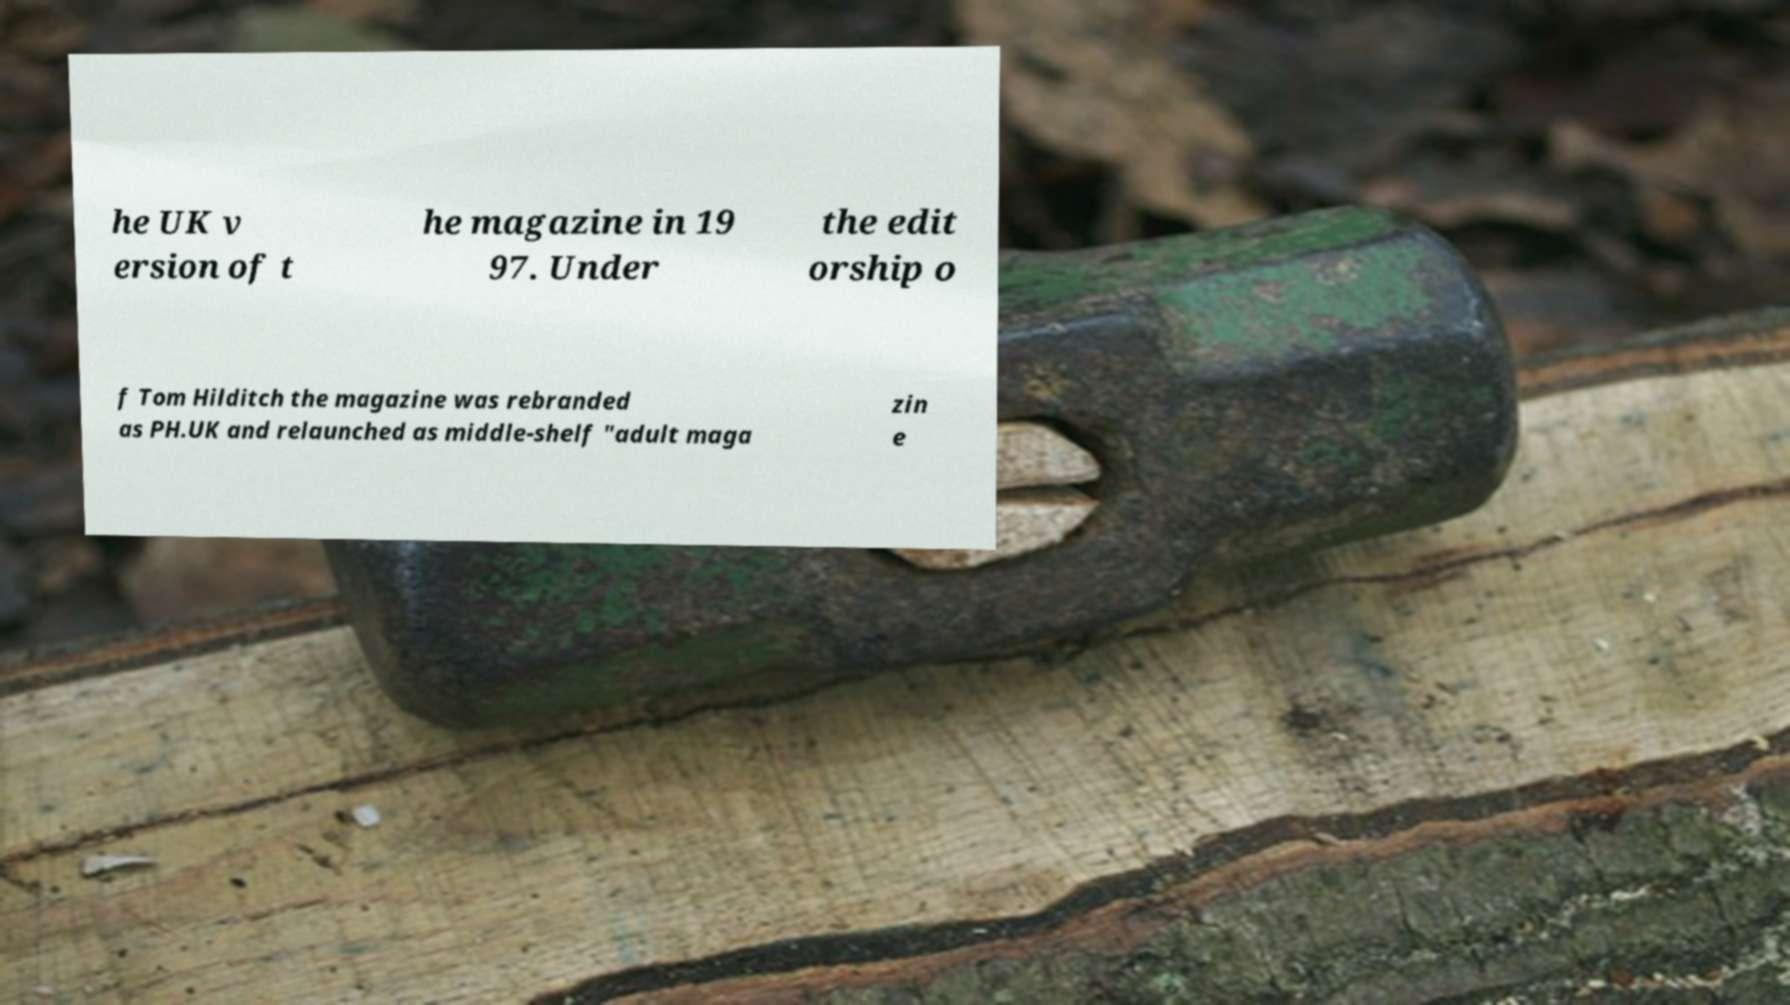I need the written content from this picture converted into text. Can you do that? he UK v ersion of t he magazine in 19 97. Under the edit orship o f Tom Hilditch the magazine was rebranded as PH.UK and relaunched as middle-shelf "adult maga zin e 